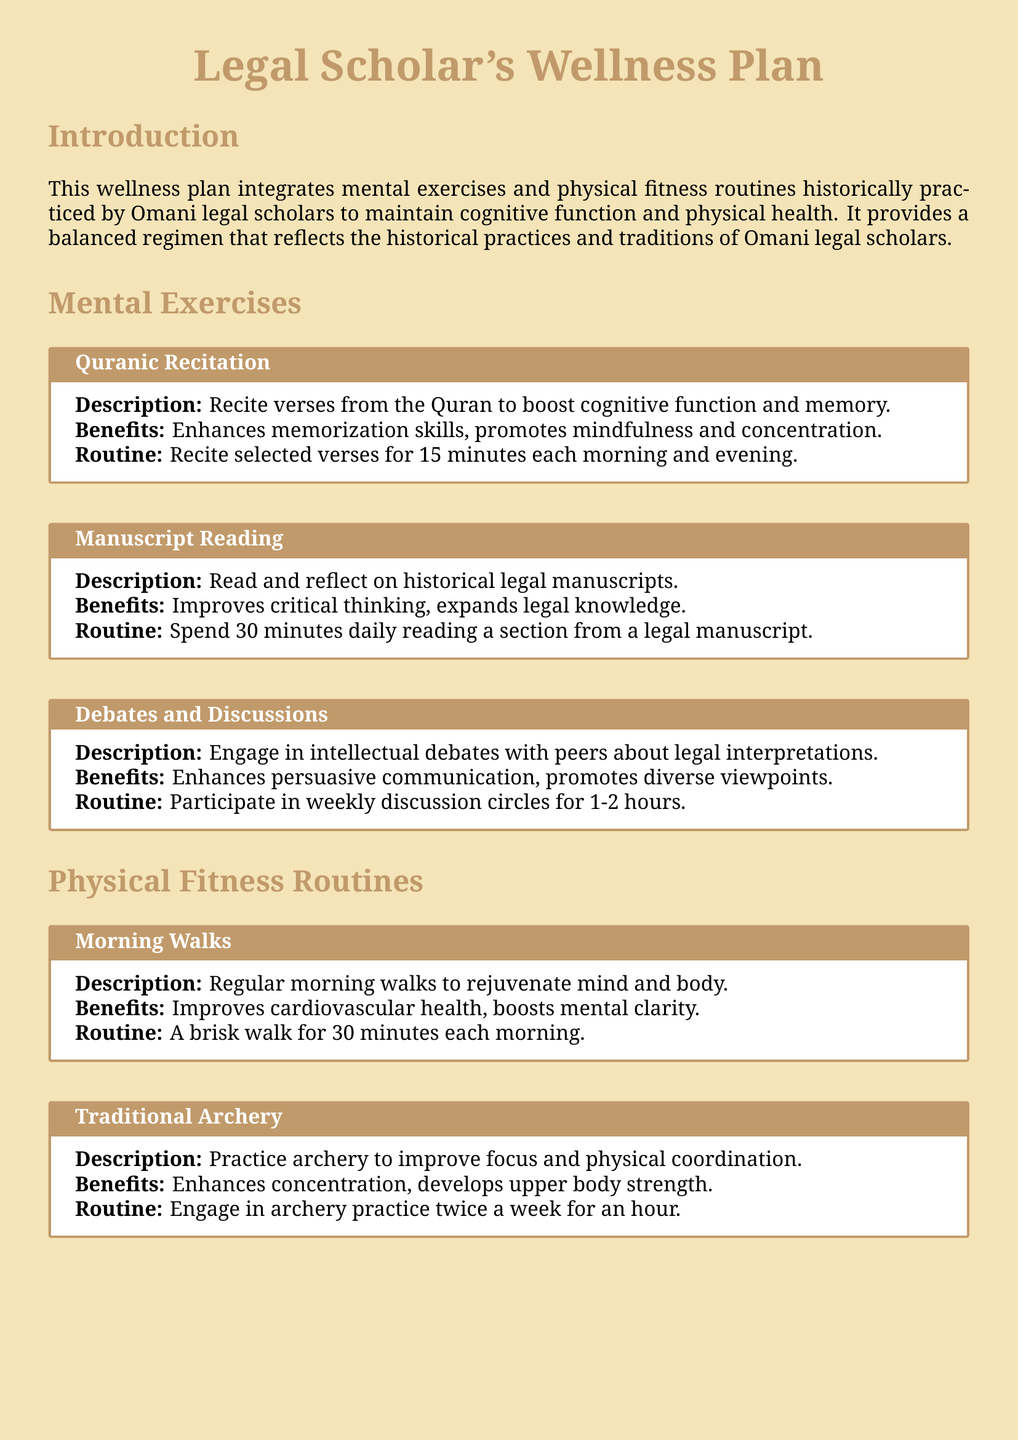What is the title of the document? The title provided at the center of the document is "Legal Scholar's Wellness Plan."
Answer: Legal Scholar's Wellness Plan How long is the routine for Quranic Recitation? The document specifies that the routine for Quranic Recitation is for 15 minutes each morning and evening.
Answer: 15 minutes What is the benefit of Traditional Archery? One of the benefits listed for Traditional Archery is that it enhances concentration.
Answer: Enhances concentration How many times a week should breathing exercises be performed? The document states that deep breathing exercises are to be performed for 10 minutes each day, which totals 7 times a week.
Answer: 7 times What activity is suggested for cognitive improvement during the daily routine? The document indicates "Manuscript Reading" as an activity suggested for cognitive improvement.
Answer: Manuscript Reading What is the duration of camel riding sessions? The document outlines that camel riding sessions should last for an hour.
Answer: One hour How often should participants engage in debates and discussions? The document recommends participation in weekly discussion circles for engaging in debates.
Answer: Weekly What type of physical exercise is recommended to improve cardiovascular health? The document suggests "Morning Walks" as a physical exercise for improving cardiovascular health.
Answer: Morning Walks 